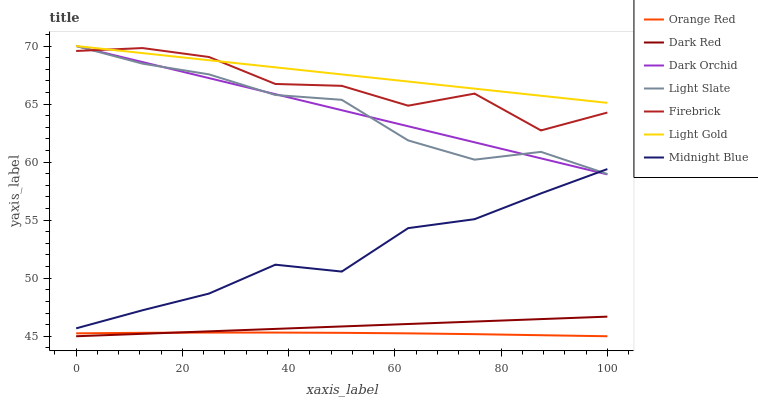Does Orange Red have the minimum area under the curve?
Answer yes or no. Yes. Does Light Gold have the maximum area under the curve?
Answer yes or no. Yes. Does Light Slate have the minimum area under the curve?
Answer yes or no. No. Does Light Slate have the maximum area under the curve?
Answer yes or no. No. Is Dark Red the smoothest?
Answer yes or no. Yes. Is Firebrick the roughest?
Answer yes or no. Yes. Is Light Slate the smoothest?
Answer yes or no. No. Is Light Slate the roughest?
Answer yes or no. No. Does Light Slate have the lowest value?
Answer yes or no. No. Does Light Gold have the highest value?
Answer yes or no. Yes. Does Dark Red have the highest value?
Answer yes or no. No. Is Dark Red less than Light Gold?
Answer yes or no. Yes. Is Firebrick greater than Dark Red?
Answer yes or no. Yes. Does Midnight Blue intersect Dark Orchid?
Answer yes or no. Yes. Is Midnight Blue less than Dark Orchid?
Answer yes or no. No. Is Midnight Blue greater than Dark Orchid?
Answer yes or no. No. Does Dark Red intersect Light Gold?
Answer yes or no. No. 